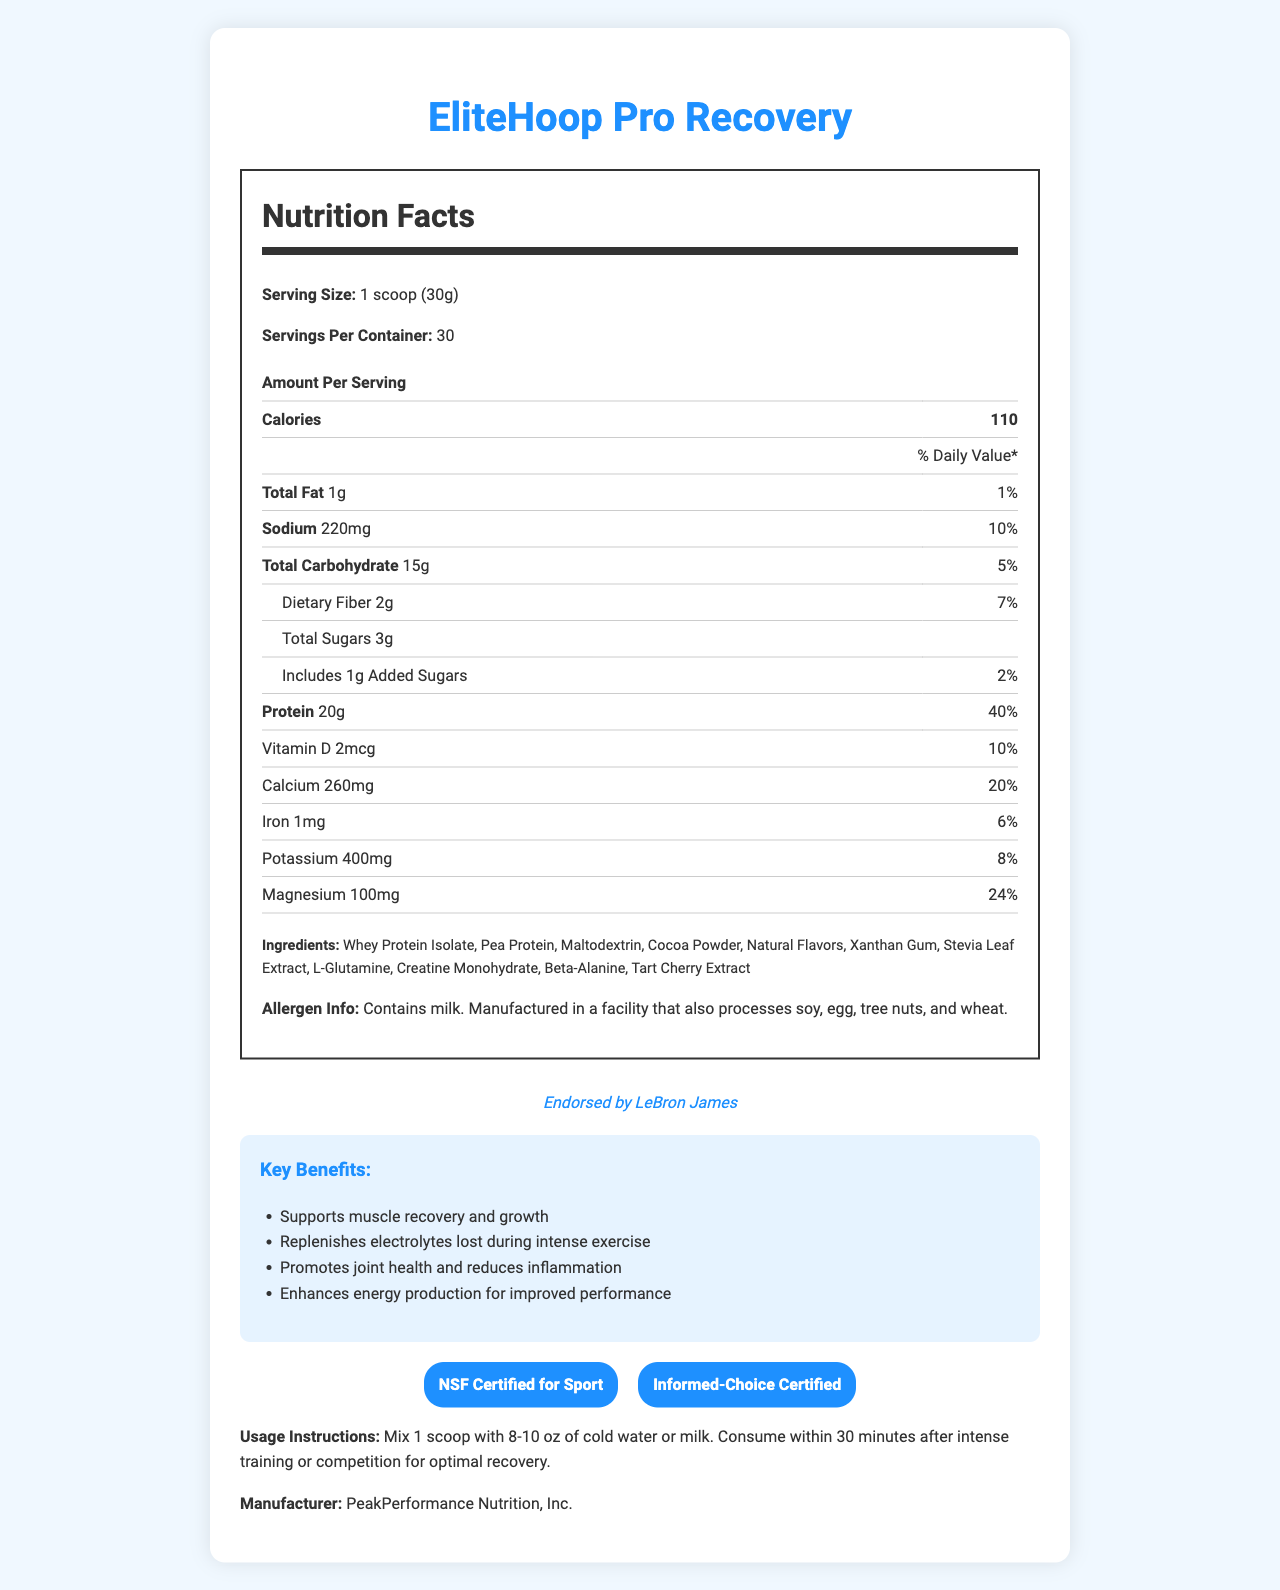what is the serving size? The serving size is indicated at the beginning of the Nutrition Facts section.
Answer: 1 scoop (30g) how many calories are in one serving? The number of calories per serving is listed as 110 in the Nutrition Facts section.
Answer: 110 what is the daily value percentage for total fat? The daily value percentage for total fat is shown as 1% in the Nutrition Facts section.
Answer: 1% how much protein is in one serving? The amount of protein per serving is specified as 20g in the Nutrition Facts section.
Answer: 20g list two key benefits of the EliteHoop Pro Recovery supplement. Two key benefits are listed in the Key Benefits section.
Answer: Supports muscle recovery and growth, Replenishes electrolytes lost during intense exercise what percentage of the daily value does magnesium contribute? Magnesium contributes 24% of the daily value as stated in the vitamins and minerals table.
Answer: 24% how many servings are in the container? The number of servings per container is specified as 30 in the Nutrition Facts section.
Answer: 30 what is the sodium content in one serving? The sodium content per serving is listed as 220mg in the Nutrition Facts section.
Answer: 220mg which professional athlete endorses this product? The product is endorsed by LeBron James, as stated in the endorsed-by section.
Answer: LeBron James what is the manufacturing company of the product? The manufacturer is listed as PeakPerformance Nutrition, Inc. at the bottom of the document.
Answer: PeakPerformance Nutrition, Inc. how much dietary fiber does one serving provide? The amount of dietary fiber per serving is indicated as 2g in the Nutrition Facts section.
Answer: 2g does this product contain any added sugars? The product includes 1g of added sugars, as shown in the Total Sugars section under Nutrition Facts.
Answer: Yes which of the following vitamins and minerals is NOT listed in the Nutrition Facts? A. Vitamin C B. Calcium C. Potassium The Nutrition Facts section lists Calcium and Potassium, but not Vitamin C.
Answer: A what is the amount of iron provided per serving, and what percentage of the daily value does it contribute? A. 2mg, 10% B. 1mg, 6% C. 4mg, 24% The Nutrition Facts section indicates that the amount of iron is 1mg, contributing 6% of the daily value.
Answer: B is the product certified for sport? The certifications listed include NSF Certified for Sport and Informed-Choice Certified.
Answer: Yes summarize the main idea of the document. The document covers various aspects of the EliteHoop Pro Recovery supplement, focusing on its nutritional benefits, key ingredients, endorsements, and usage instructions for optimal recovery after intense training or competition.
Answer: The document provides detailed nutritional information, ingredients, benefits, usage instructions, certifications, and endorsements of the EliteHoop Pro Recovery supplement. It is designed to support muscle recovery and growth, replenishes electrolytes, promotes joint health, and enhances energy production. is tart cherry extract an ingredient in the product? Tart cherry extract is listed as one of the ingredients in the Ingredients section.
Answer: Yes how should the supplement be consumed for optimal recovery? The usage instructions state to mix 1 scoop with 8-10 oz of cold water or milk and consume within 30 minutes after intense training for optimal recovery.
Answer: Mix 1 scoop with 8-10 oz of cold water or milk and consume within 30 minutes after intense training or competition. what is the primary target demographic for this product? The document provides nutritional information and endorsements but does not specify the primary target demographic.
Answer: Cannot be determined what is the total amount of sugar per serving, including added sugars? The total amount of sugar per serving is 3g, which includes 1g of added sugars.
Answer: 3g 